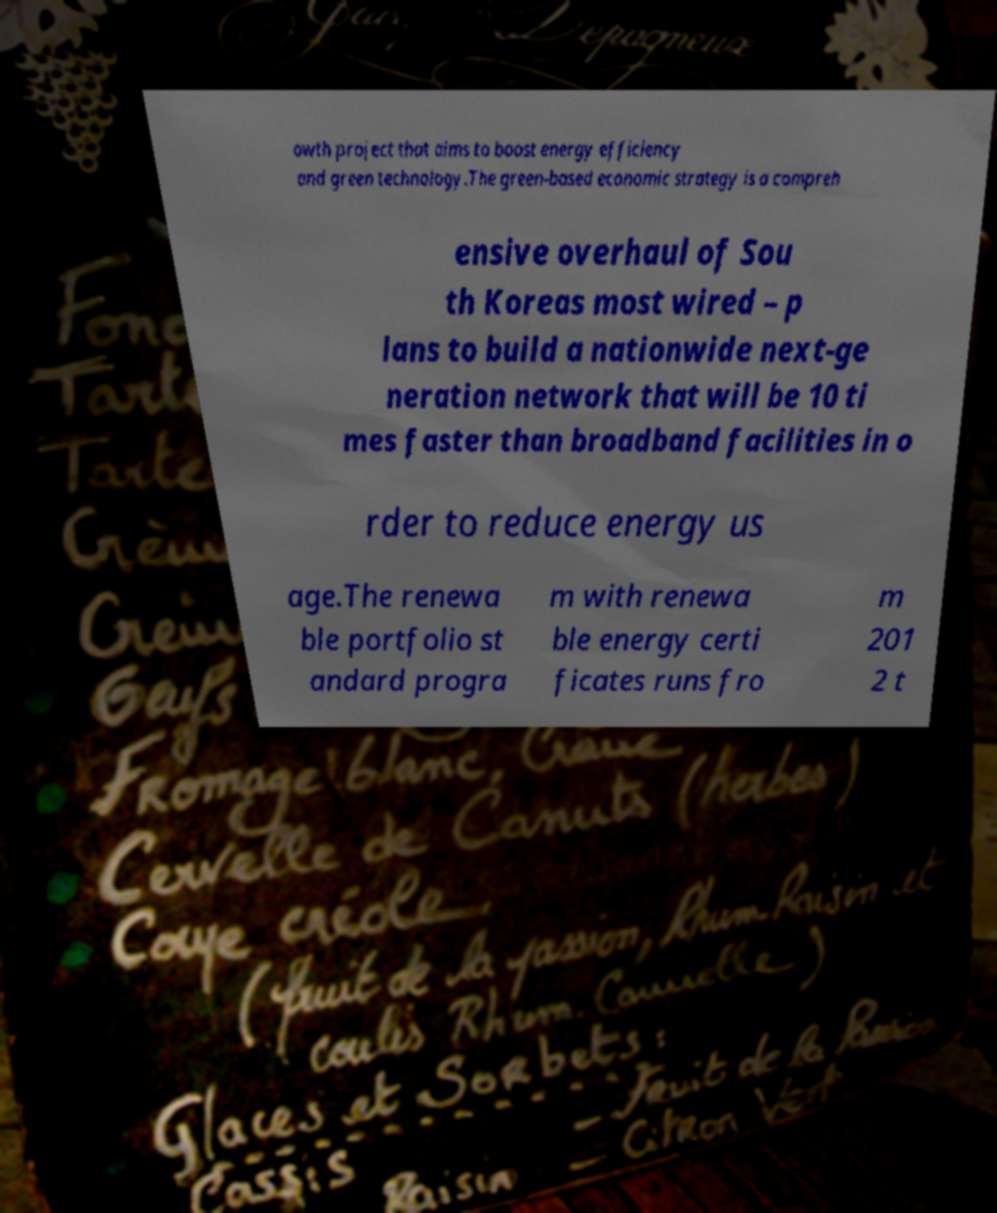I need the written content from this picture converted into text. Can you do that? owth project that aims to boost energy efficiency and green technology.The green-based economic strategy is a compreh ensive overhaul of Sou th Koreas most wired – p lans to build a nationwide next-ge neration network that will be 10 ti mes faster than broadband facilities in o rder to reduce energy us age.The renewa ble portfolio st andard progra m with renewa ble energy certi ficates runs fro m 201 2 t 